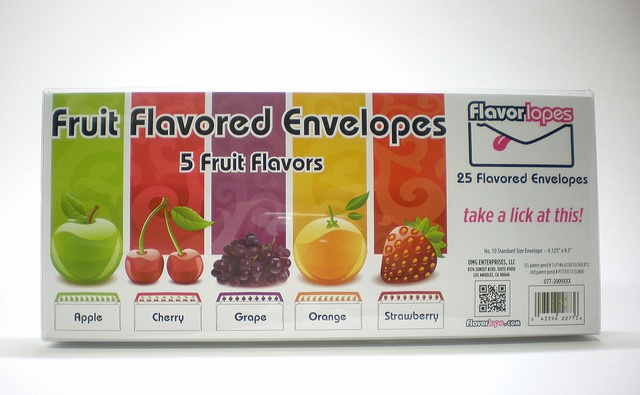Describe the objects in this image and their specific colors. I can see orange in lightgray, orange, tan, and khaki tones and apple in lightgray, olive, and khaki tones in this image. 